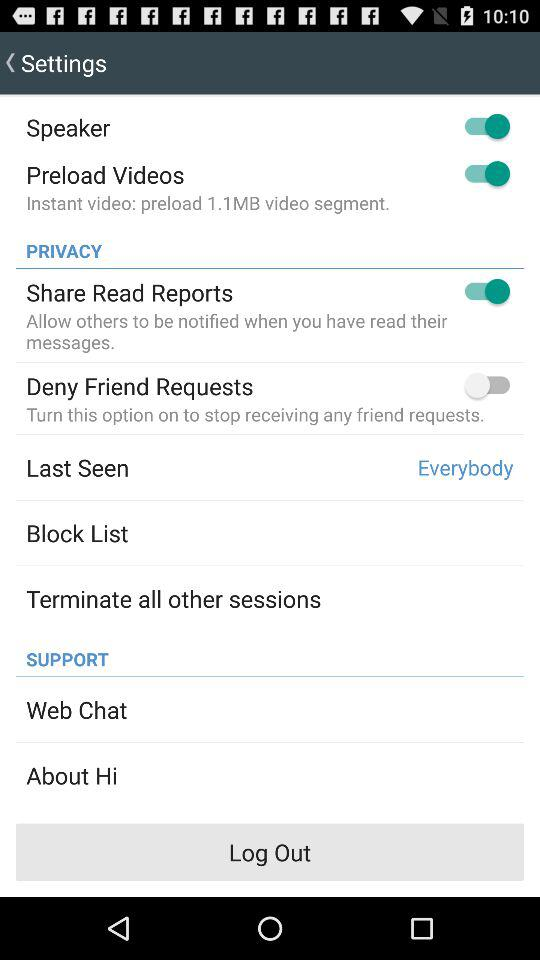What is the status of "Speaker"? The status of "Speaker" is "on". 